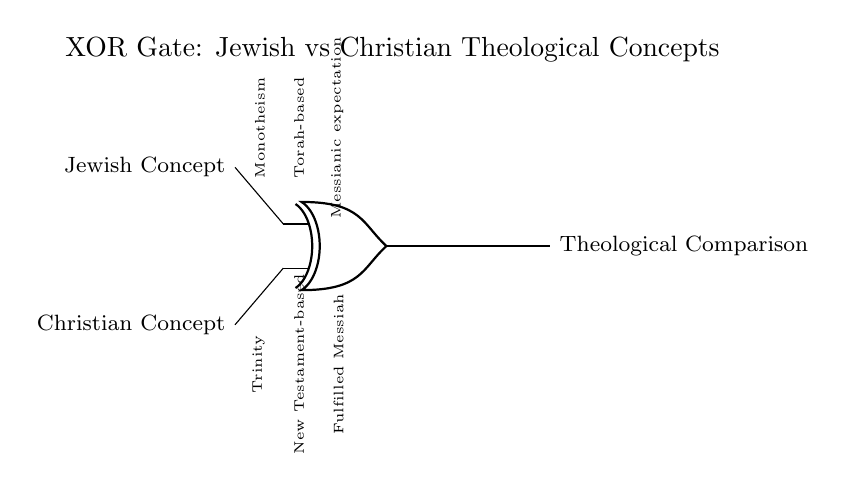What are the two inputs of the XOR gate? The inputs are labeled as "Jewish Concept" and "Christian Concept" in the circuit.
Answer: Jewish Concept, Christian Concept What theological concept is highlighted at the output? The output is labeled as "Theological Comparison," signifying the result of the XOR operation between the two inputs.
Answer: Theological Comparison What are the two core ideas associated with the Jewish input? The Jewish concepts are "Monotheism," "Torah-based," and "Messianic expectation," as indicated in the diagram.
Answer: Monotheism, Torah-based, Messianic expectation What are the two core ideas associated with the Christian input? The Christian concepts are "Trinity," "New Testament-based," and "Fulfilled Messiah," which are provided as the inputs to the XOR gate.
Answer: Trinity, New Testament-based, Fulfilled Messiah Why is this an XOR gate instead of another type? An XOR (exclusive OR) gate outputs true only when one input is true and the other is false. This reflects the unique theological differences highlighted between Jewish and Christian beliefs.
Answer: Unique differences How does the concept of Monotheism compare to the Trinity in this circuit? Monotheism reflects a single divine entity in Judaism, whereas the Trinity represents a complex concept of three divine persons in Christianity, showcasing a fundamental theological contrast.
Answer: Fundamental contrast What is implied by the labels "Fulfilled Messiah" in relation to the Jewish expectations? "Fulfilled Messiah" suggests that Christian theology views Jesus as the realization of Jewish Messianic expectations, indicating a significant theological intersection and divergence between the two traditions.
Answer: Significant theological intersection 